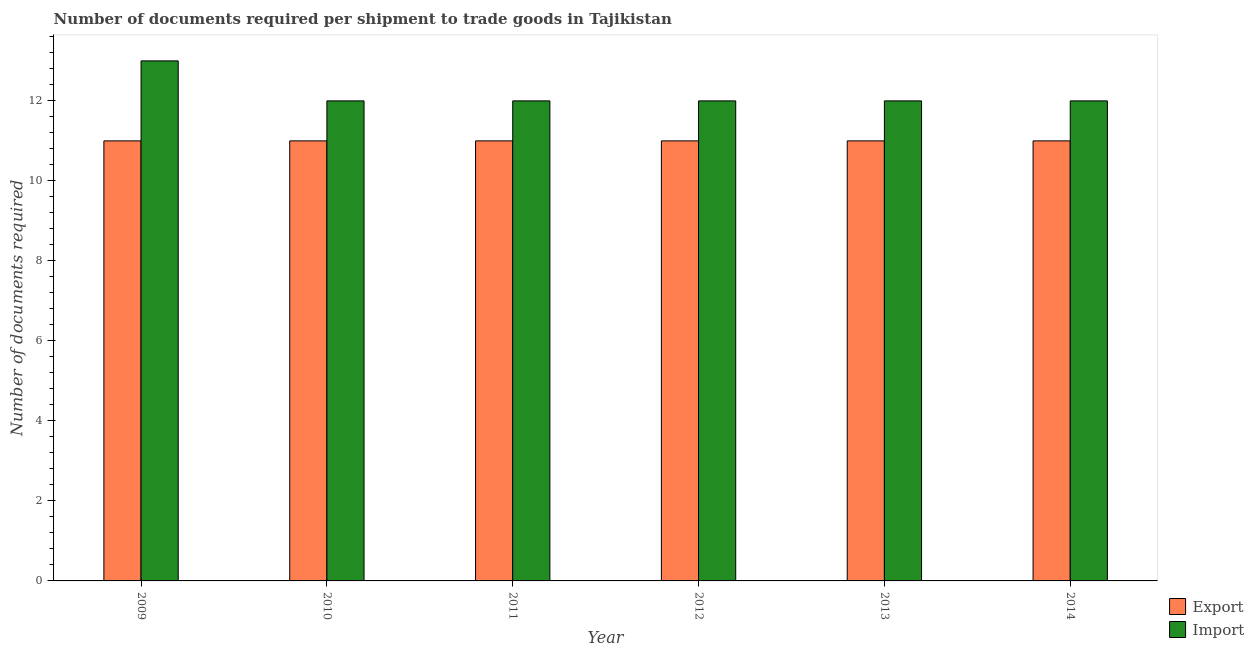How many different coloured bars are there?
Provide a succinct answer. 2. How many groups of bars are there?
Offer a very short reply. 6. Are the number of bars on each tick of the X-axis equal?
Offer a terse response. Yes. How many bars are there on the 4th tick from the left?
Ensure brevity in your answer.  2. How many bars are there on the 4th tick from the right?
Your answer should be very brief. 2. What is the number of documents required to import goods in 2010?
Offer a terse response. 12. Across all years, what is the maximum number of documents required to import goods?
Provide a succinct answer. 13. Across all years, what is the minimum number of documents required to export goods?
Make the answer very short. 11. In which year was the number of documents required to export goods minimum?
Provide a succinct answer. 2009. What is the total number of documents required to import goods in the graph?
Keep it short and to the point. 73. What is the difference between the number of documents required to import goods in 2010 and that in 2013?
Provide a succinct answer. 0. In the year 2011, what is the difference between the number of documents required to export goods and number of documents required to import goods?
Offer a terse response. 0. In how many years, is the number of documents required to import goods greater than 0.8?
Offer a very short reply. 6. What is the ratio of the number of documents required to import goods in 2009 to that in 2012?
Offer a terse response. 1.08. What is the difference between the highest and the second highest number of documents required to import goods?
Your answer should be compact. 1. What is the difference between the highest and the lowest number of documents required to import goods?
Keep it short and to the point. 1. What does the 2nd bar from the left in 2009 represents?
Offer a very short reply. Import. What does the 2nd bar from the right in 2010 represents?
Provide a short and direct response. Export. Are all the bars in the graph horizontal?
Provide a short and direct response. No. What is the difference between two consecutive major ticks on the Y-axis?
Offer a very short reply. 2. How many legend labels are there?
Your response must be concise. 2. How are the legend labels stacked?
Your response must be concise. Vertical. What is the title of the graph?
Your answer should be compact. Number of documents required per shipment to trade goods in Tajikistan. Does "Primary school" appear as one of the legend labels in the graph?
Keep it short and to the point. No. What is the label or title of the X-axis?
Give a very brief answer. Year. What is the label or title of the Y-axis?
Provide a short and direct response. Number of documents required. What is the Number of documents required of Export in 2010?
Give a very brief answer. 11. What is the Number of documents required of Export in 2011?
Your response must be concise. 11. What is the Number of documents required in Import in 2011?
Ensure brevity in your answer.  12. What is the Number of documents required of Import in 2012?
Offer a very short reply. 12. What is the Number of documents required of Import in 2013?
Offer a terse response. 12. What is the Number of documents required of Export in 2014?
Keep it short and to the point. 11. What is the total Number of documents required of Export in the graph?
Keep it short and to the point. 66. What is the difference between the Number of documents required of Export in 2009 and that in 2010?
Your answer should be very brief. 0. What is the difference between the Number of documents required in Import in 2009 and that in 2011?
Offer a very short reply. 1. What is the difference between the Number of documents required of Export in 2009 and that in 2012?
Provide a succinct answer. 0. What is the difference between the Number of documents required of Import in 2009 and that in 2012?
Provide a succinct answer. 1. What is the difference between the Number of documents required of Export in 2009 and that in 2013?
Provide a succinct answer. 0. What is the difference between the Number of documents required of Import in 2009 and that in 2013?
Ensure brevity in your answer.  1. What is the difference between the Number of documents required of Import in 2009 and that in 2014?
Give a very brief answer. 1. What is the difference between the Number of documents required in Export in 2010 and that in 2011?
Offer a terse response. 0. What is the difference between the Number of documents required of Import in 2010 and that in 2011?
Make the answer very short. 0. What is the difference between the Number of documents required in Export in 2010 and that in 2014?
Ensure brevity in your answer.  0. What is the difference between the Number of documents required in Export in 2011 and that in 2012?
Provide a short and direct response. 0. What is the difference between the Number of documents required in Export in 2011 and that in 2013?
Provide a succinct answer. 0. What is the difference between the Number of documents required in Import in 2011 and that in 2013?
Provide a succinct answer. 0. What is the difference between the Number of documents required in Export in 2011 and that in 2014?
Provide a short and direct response. 0. What is the difference between the Number of documents required in Export in 2012 and that in 2013?
Your answer should be compact. 0. What is the difference between the Number of documents required in Import in 2012 and that in 2013?
Offer a terse response. 0. What is the difference between the Number of documents required of Import in 2012 and that in 2014?
Your response must be concise. 0. What is the difference between the Number of documents required in Export in 2013 and that in 2014?
Your response must be concise. 0. What is the difference between the Number of documents required of Import in 2013 and that in 2014?
Your answer should be compact. 0. What is the difference between the Number of documents required in Export in 2009 and the Number of documents required in Import in 2010?
Offer a very short reply. -1. What is the difference between the Number of documents required of Export in 2009 and the Number of documents required of Import in 2011?
Give a very brief answer. -1. What is the difference between the Number of documents required of Export in 2009 and the Number of documents required of Import in 2012?
Your answer should be very brief. -1. What is the difference between the Number of documents required of Export in 2009 and the Number of documents required of Import in 2013?
Provide a succinct answer. -1. What is the difference between the Number of documents required of Export in 2009 and the Number of documents required of Import in 2014?
Give a very brief answer. -1. What is the difference between the Number of documents required in Export in 2010 and the Number of documents required in Import in 2014?
Offer a very short reply. -1. What is the difference between the Number of documents required in Export in 2011 and the Number of documents required in Import in 2013?
Offer a terse response. -1. What is the difference between the Number of documents required of Export in 2013 and the Number of documents required of Import in 2014?
Your answer should be compact. -1. What is the average Number of documents required of Export per year?
Make the answer very short. 11. What is the average Number of documents required in Import per year?
Your answer should be compact. 12.17. In the year 2009, what is the difference between the Number of documents required of Export and Number of documents required of Import?
Keep it short and to the point. -2. In the year 2011, what is the difference between the Number of documents required in Export and Number of documents required in Import?
Offer a very short reply. -1. In the year 2012, what is the difference between the Number of documents required of Export and Number of documents required of Import?
Make the answer very short. -1. In the year 2013, what is the difference between the Number of documents required in Export and Number of documents required in Import?
Keep it short and to the point. -1. What is the ratio of the Number of documents required of Export in 2009 to that in 2010?
Offer a terse response. 1. What is the ratio of the Number of documents required in Import in 2009 to that in 2010?
Make the answer very short. 1.08. What is the ratio of the Number of documents required in Export in 2009 to that in 2011?
Ensure brevity in your answer.  1. What is the ratio of the Number of documents required of Export in 2009 to that in 2012?
Make the answer very short. 1. What is the ratio of the Number of documents required in Export in 2009 to that in 2013?
Give a very brief answer. 1. What is the ratio of the Number of documents required in Import in 2010 to that in 2011?
Keep it short and to the point. 1. What is the ratio of the Number of documents required of Import in 2010 to that in 2012?
Make the answer very short. 1. What is the ratio of the Number of documents required in Export in 2010 to that in 2013?
Offer a terse response. 1. What is the ratio of the Number of documents required in Import in 2010 to that in 2013?
Offer a very short reply. 1. What is the ratio of the Number of documents required of Export in 2011 to that in 2012?
Ensure brevity in your answer.  1. What is the ratio of the Number of documents required in Import in 2011 to that in 2012?
Provide a short and direct response. 1. What is the ratio of the Number of documents required in Export in 2011 to that in 2013?
Make the answer very short. 1. What is the ratio of the Number of documents required of Export in 2012 to that in 2013?
Your response must be concise. 1. What is the ratio of the Number of documents required of Import in 2012 to that in 2013?
Ensure brevity in your answer.  1. What is the ratio of the Number of documents required in Export in 2012 to that in 2014?
Your answer should be very brief. 1. What is the ratio of the Number of documents required of Import in 2012 to that in 2014?
Provide a succinct answer. 1. What is the ratio of the Number of documents required of Import in 2013 to that in 2014?
Give a very brief answer. 1. What is the difference between the highest and the second highest Number of documents required of Export?
Give a very brief answer. 0. What is the difference between the highest and the second highest Number of documents required in Import?
Your answer should be very brief. 1. 